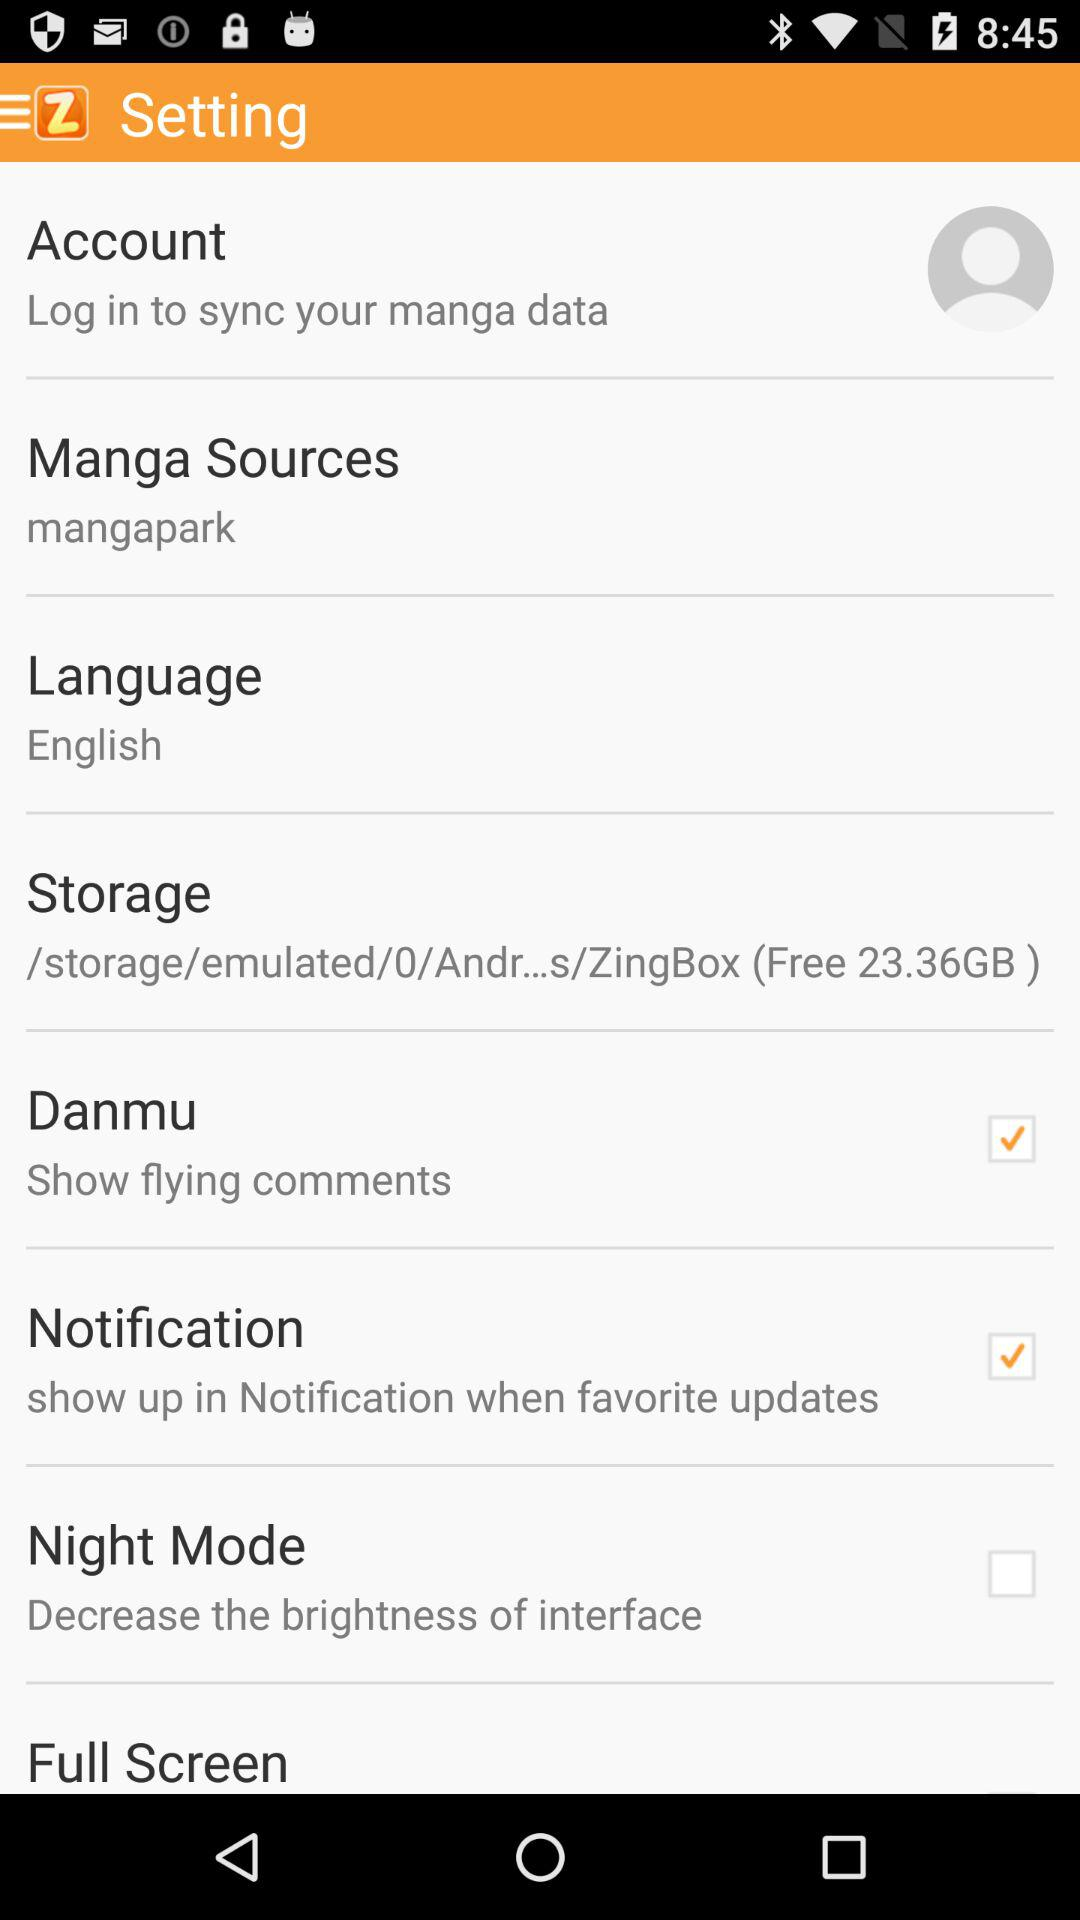How to sync the manga data? You have to log in to sync the manga data. 